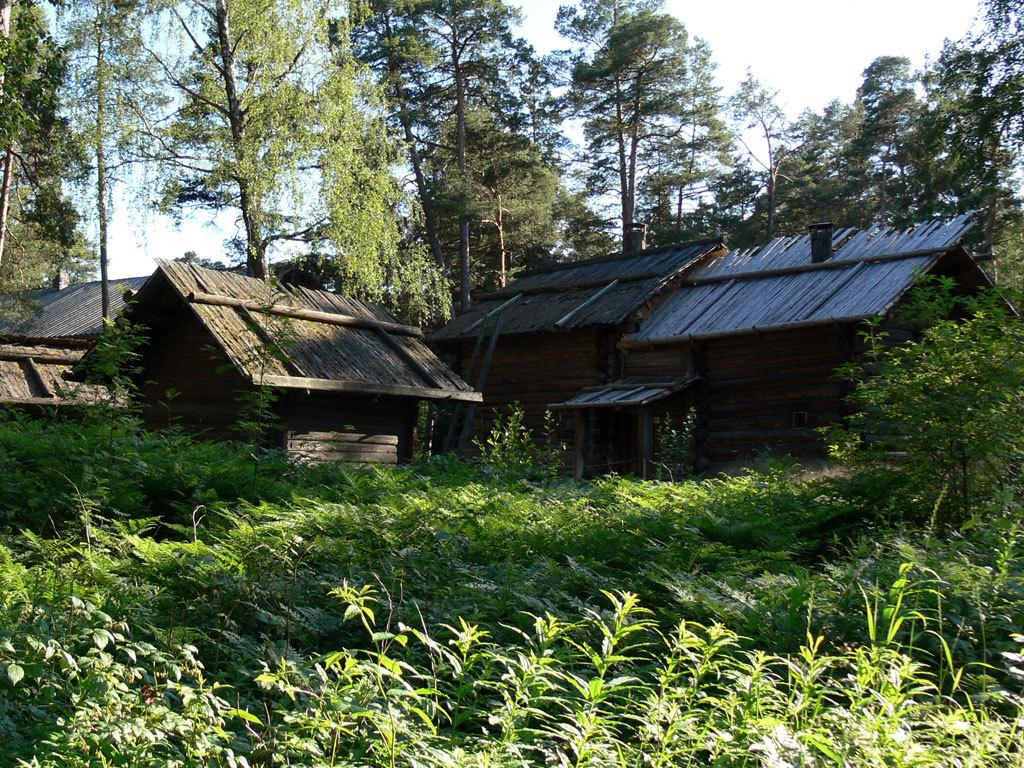What structures are located in the middle of the picture? There are houses in the middle of the picture. What is in front of the houses? There are plants and grass in front of the houses. What can be seen in the background of the picture? There are trees and the sky visible in the background of the picture. What type of sail can be seen on the roof of the houses in the image? There is no sail present on the roofs of the houses in the image. What kind of pancake is being served on the grass in front of the houses? There is no pancake present on the grass in front of the houses in the image. 